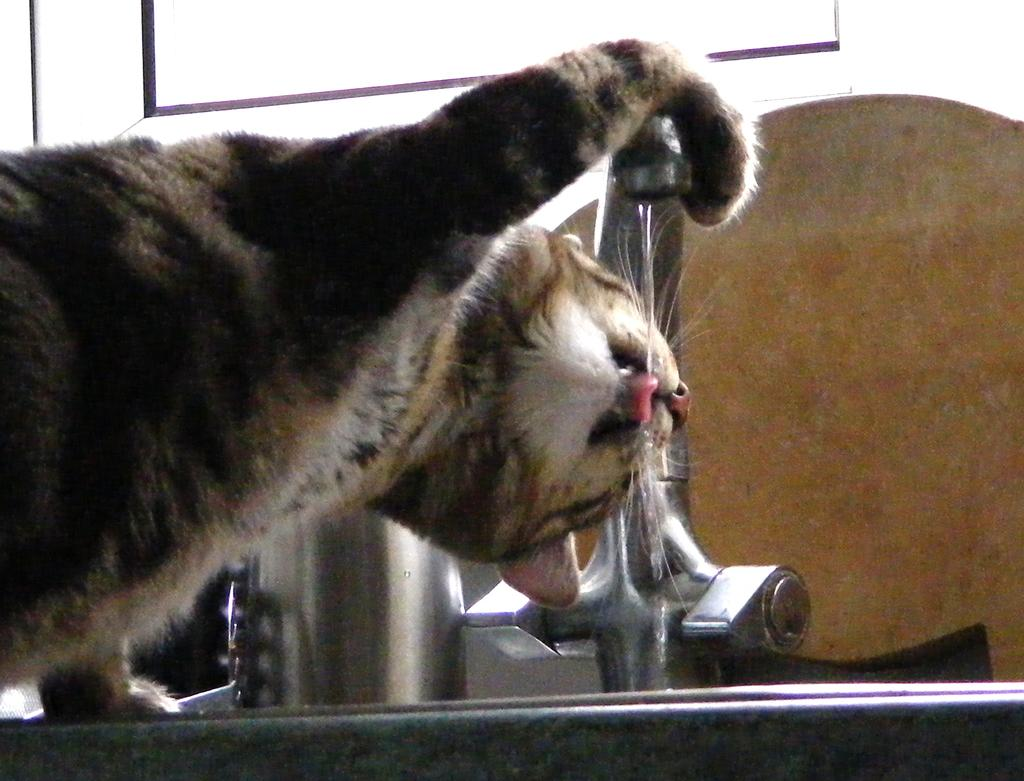What type of animal can be seen in the picture? There is a cat in the picture. What is the purpose of the object with a handle and a spout in the picture? There is a tap in the picture, which is used for controlling the flow of water. Can you describe the liquid visible in the picture? There is water visible in the picture. What other objects can be seen in the picture besides the cat and the tap? There are other objects in the picture, but their specific details are not mentioned in the provided facts. What is the location of the window in the picture? There is a window at the top of the picture. What type of print can be seen on the cat's fur in the picture? There is no mention of a print on the cat's fur in the provided facts, and therefore it cannot be determined from the image. What is the purpose of the downtown area in the picture? There is no mention of a downtown area in the provided facts, and therefore it cannot be determined from the image. 